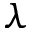Convert formula to latex. <formula><loc_0><loc_0><loc_500><loc_500>\lambda</formula> 